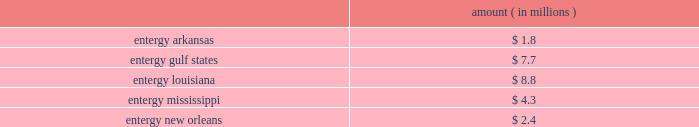Domestic utility companies and system energy notes to respective financial statements protested the disallowance of these deductions to the office of irs appeals .
Entergy expects to receive a notice of deficiency in 2005 for this item , and plans to vigorously contest this matter .
Entergy believes that the contingency provision established in its financial statements sufficiently covers the risk associated with this item .
Mark to market of certain power contracts in 2001 , entergy louisiana changed its method of accounting for tax purposes related to its wholesale electric power contracts .
The most significant of these is the contract to purchase power from the vidalia hydroelectric project .
The new tax accounting method has provided a cumulative cash flow benefit of approximately $ 790 million as of december 31 , 2004 .
The related irs interest exposure is $ 93 million at december 31 , 2004 .
This benefit is expected to reverse in the years 2005 through 2031 .
The election did not reduce book income tax expense .
The timing of the reversal of this benefit depends on several variables , including the price of power .
Due to the temporary nature of the tax benefit , the potential interest charge represents entergy's net earnings exposure .
Entergy louisiana's 2001 tax return is currently under examination by the irs , though no adjustments have yet been proposed with respect to the mark to market election .
Entergy believes that the contingency provision established in its financial statements will sufficiently cover the risk associated with this issue .
Cashpoint bankruptcy ( entergy arkansas , entergy gulf states , entergy louisiana , entergy mississippi , and entergy new orleans ) in 2003 the domestic utility companies entered an agreement with cashpoint network services ( cashpoint ) under which cashpoint was to manage a network of payment agents through which entergy's utility customers could pay their bills .
The payment agent system allows customers to pay their bills at various commercial or governmental locations , rather than sending payments by mail .
Approximately one-third of entergy's utility customers use payment agents .
On april 19 , 2004 , cashpoint failed to pay funds due to the domestic utility companies that had been collected through payment agents .
The domestic utility companies then obtained a temporary restraining order from the civil district court for the parish of orleans , state of louisiana , enjoining cashpoint from distributing funds belonging to entergy , except by paying those funds to entergy .
On april 22 , 2004 , a petition for involuntary chapter 7 bankruptcy was filed against cashpoint by other creditors in the united states bankruptcy court for the southern district of new york .
In response to these events , the domestic utility companies expanded an existing contract with another company to manage all of their payment agents .
The domestic utility companies filed proofs of claim in the cashpoint bankruptcy proceeding in september 2004 .
Although entergy cannot precisely determine at this time the amount that cashpoint owes to the domestic utility companies that may not be repaid , it has accrued an estimate of loss based on current information .
If no cash is repaid to the domestic utility companies , an event entergy does not believe is likely , the current estimates of maximum exposure to loss are approximately as follows : amount ( in millions ) .
Environmental issues ( entergy gulf states ) entergy gulf states has been designated as a prp for the cleanup of certain hazardous waste disposal sites .
As of december 31 , 2004 , entergy gulf states does not expect the remaining clean-up costs to exceed its recorded liability of $ 1.5 million for the remaining sites at which the epa has designated entergy gulf states as a prp. .
What is the recorded liability of remaining clean-up costs as of december 31 , 2004 as a percentage of the current estimates of maximum exposure to loss for entergy gulf states? 
Computations: (1.5 / 7.7)
Answer: 0.19481. 